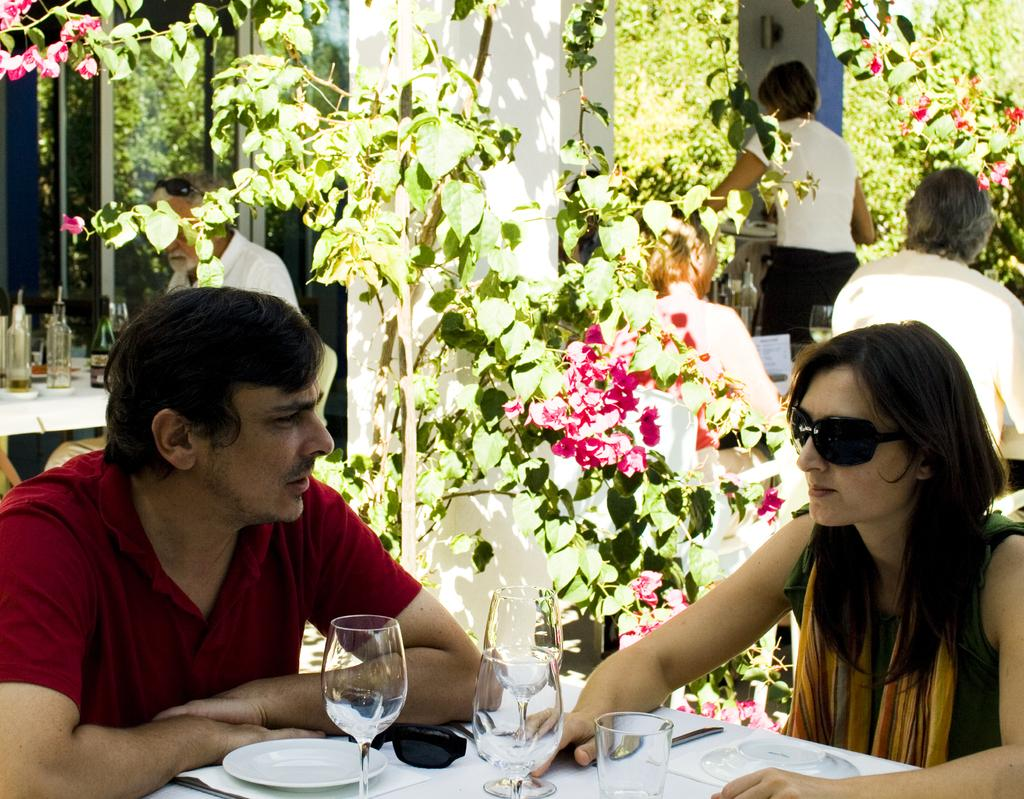How many people are present in the image? There is a man and a woman in the image. What can be seen in the background of the image? There is a plant in the background of the image. What type of spark can be seen coming from the woman's hand in the image? There is no spark present in the image; both the man and the woman appear to be standing normally. 